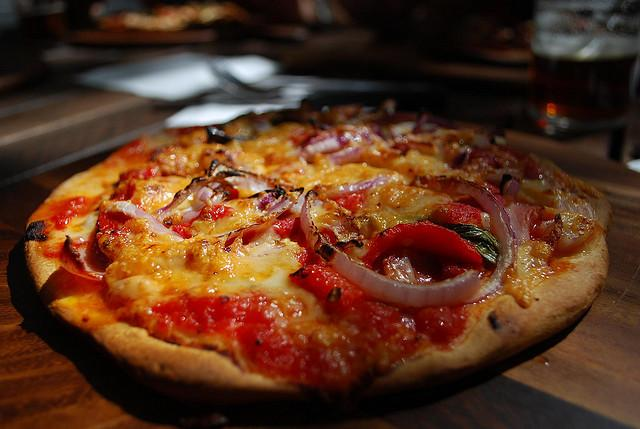The white round item on top of this food is part of what other food item? Please explain your reasoning. onion rings. These are onions, and onion rings are made out of the same thing, just covered in batter. 